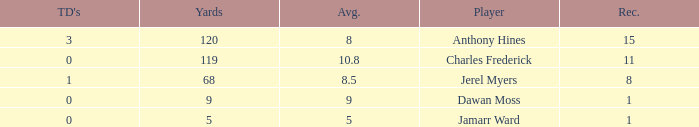What is the highest number of TDs when the Avg is larger than 8.5 and the Rec is less than 1? None. 